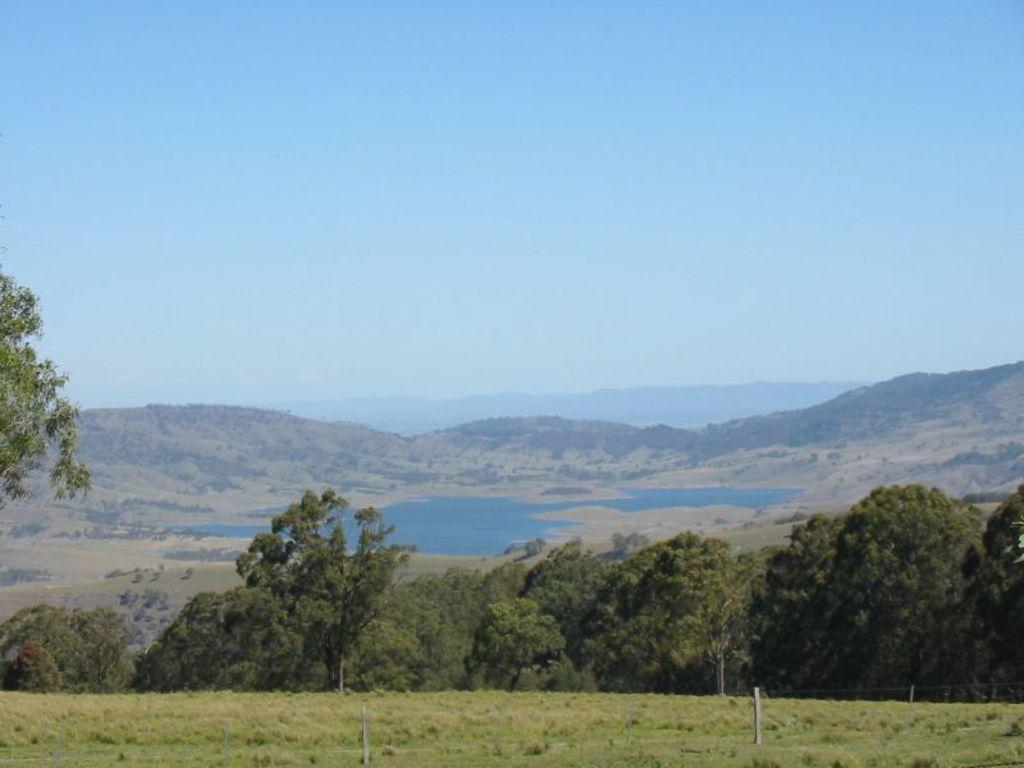Describe this image in one or two sentences. These are the trees. This looks like a grass. I can see the hills. I think these are the water. This is the sky. 